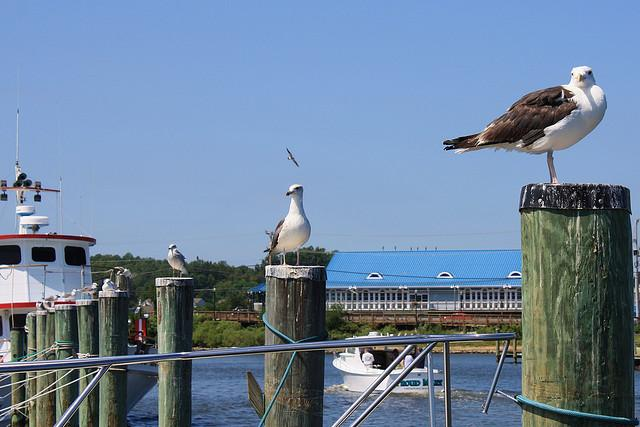What vessels are tied to the piers here?

Choices:
A) cars
B) rafts
C) boats
D) horse buggies boats 